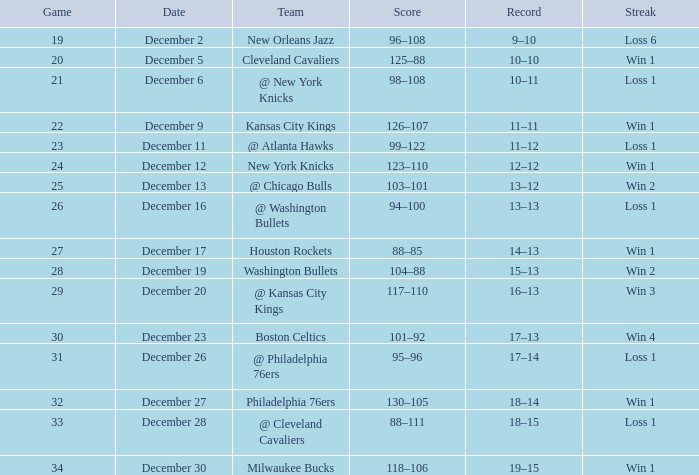What is the sequence on december 30? Win 1. 